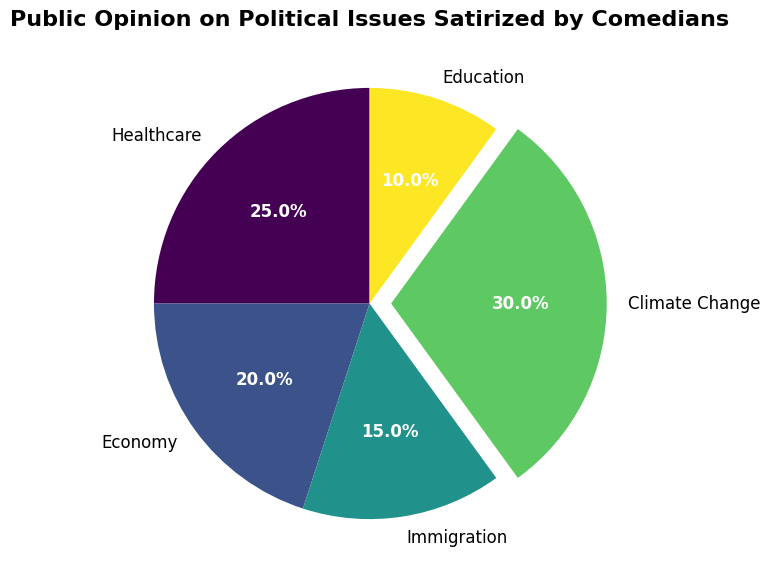What political issue has the highest public support? The sector with the highest percentage is visually noticeable as the largest one and exploded. The sector is for 'Climate Change' with a public support of 30%.
Answer: Climate Change Which two issues combined have a total public support of 35%? Looking at the percentages in the pie chart, adding the public support for 'Immigration' (15%) and 'Education' (10%) gives a total of 25%. However, adding 'Economy' (20%) and 'Education' (10%) sums up to 30%. The correct pair that sums up to 35% is 'Economy' (20%) and 'Healthcare' (25%).
Answer: Economy and Healthcare Which issue has the least public support and what is its percentage? The smallest sector in the pie chart represents 'Education', which has a public support of 10%.
Answer: Education, 10% What is the difference in public support between Climate Change and Immigration? Finding the difference between 'Climate Change' (30%) and 'Immigration' (15%) involves subtracting the latter from the former: 30% - 15% = 15%.
Answer: 15% What percentage of public support does the Economy receive related to Healthcare? The pie chart shows 25% for Healthcare and 20% for Economy. By comparing these two figures, it can be stated that the Economy receives 5% less support than Healthcare.
Answer: 5% Which two issues together constitute the majority of public support in the pie chart? The issues 'Healthcare' and 'Climate Change' together (25% + 30% = 55%) constitute more than half (the majority) of the public support.
Answer: Healthcare and Climate Change How much more public support does Climate Change have compared to Education? The public support of 'Climate Change' is 30%, and for 'Education' it is 10%. The difference is calculated as 30% - 10% = 20%.
Answer: 20% Identify the issue that occupies the second-largest segment. The pie chart visually shows the largest segment as 'Climate Change' and the second-largest segment as 'Healthcare' with 25%.
Answer: Healthcare 